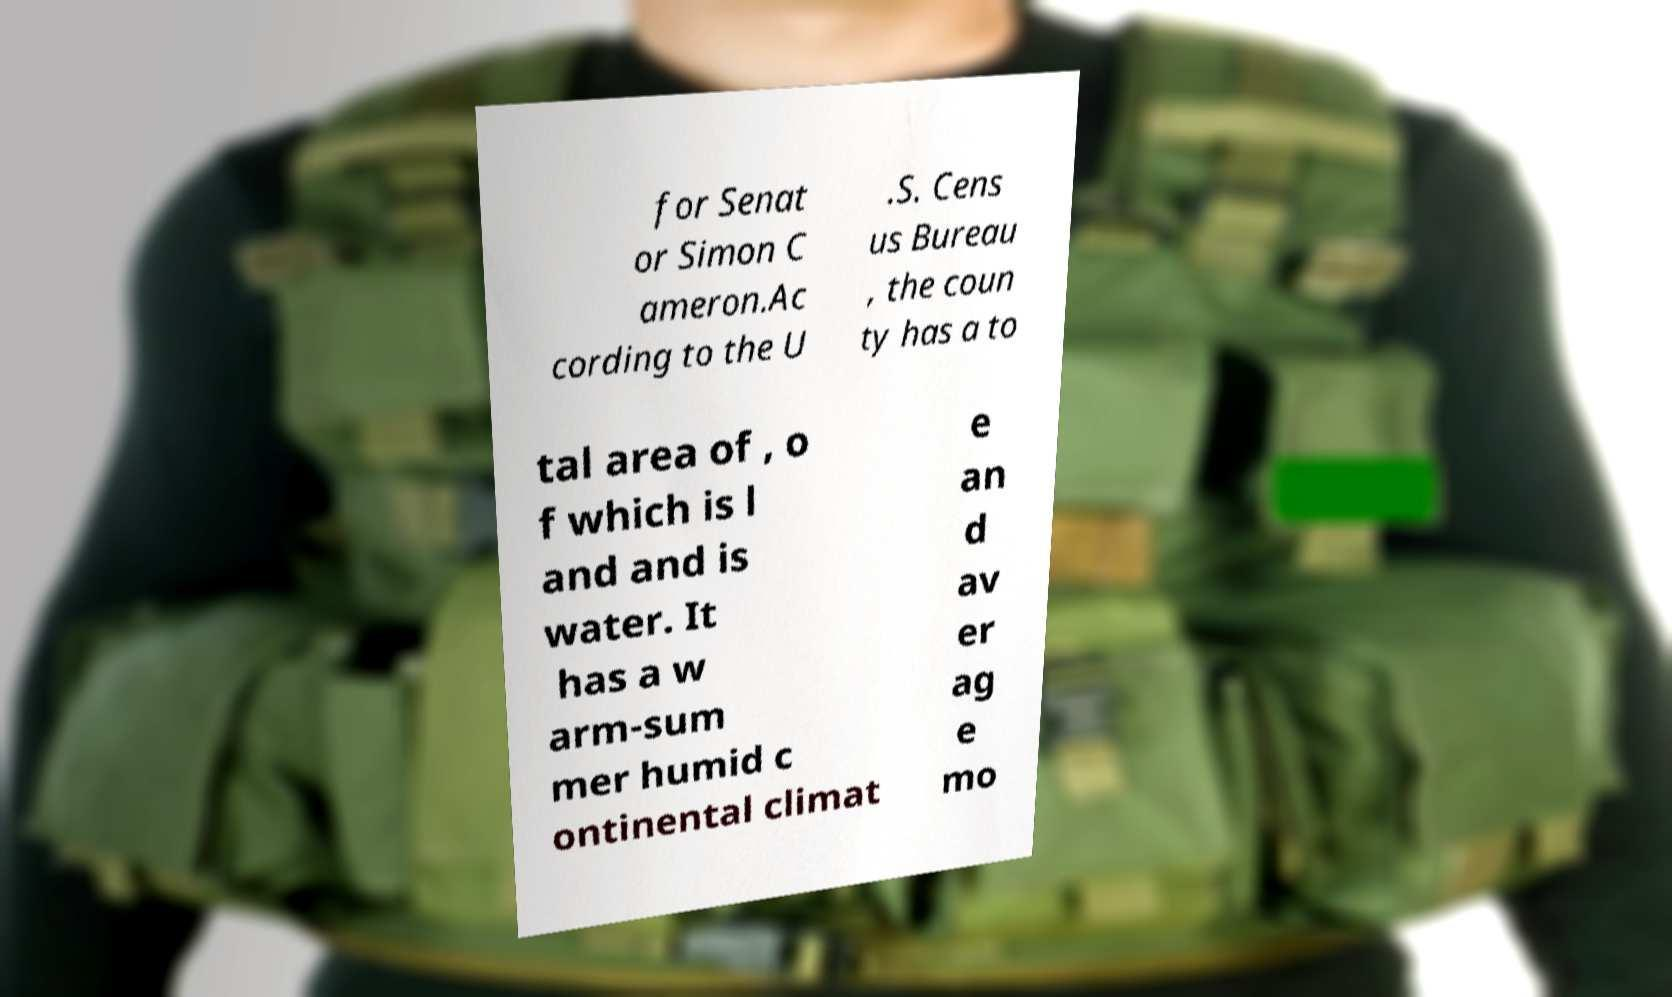What messages or text are displayed in this image? I need them in a readable, typed format. for Senat or Simon C ameron.Ac cording to the U .S. Cens us Bureau , the coun ty has a to tal area of , o f which is l and and is water. It has a w arm-sum mer humid c ontinental climat e an d av er ag e mo 